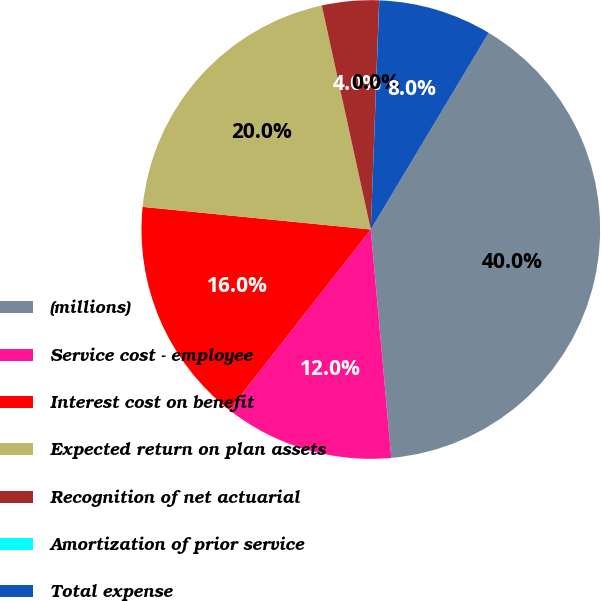<chart> <loc_0><loc_0><loc_500><loc_500><pie_chart><fcel>(millions)<fcel>Service cost - employee<fcel>Interest cost on benefit<fcel>Expected return on plan assets<fcel>Recognition of net actuarial<fcel>Amortization of prior service<fcel>Total expense<nl><fcel>39.99%<fcel>12.0%<fcel>16.0%<fcel>20.0%<fcel>4.01%<fcel>0.01%<fcel>8.0%<nl></chart> 